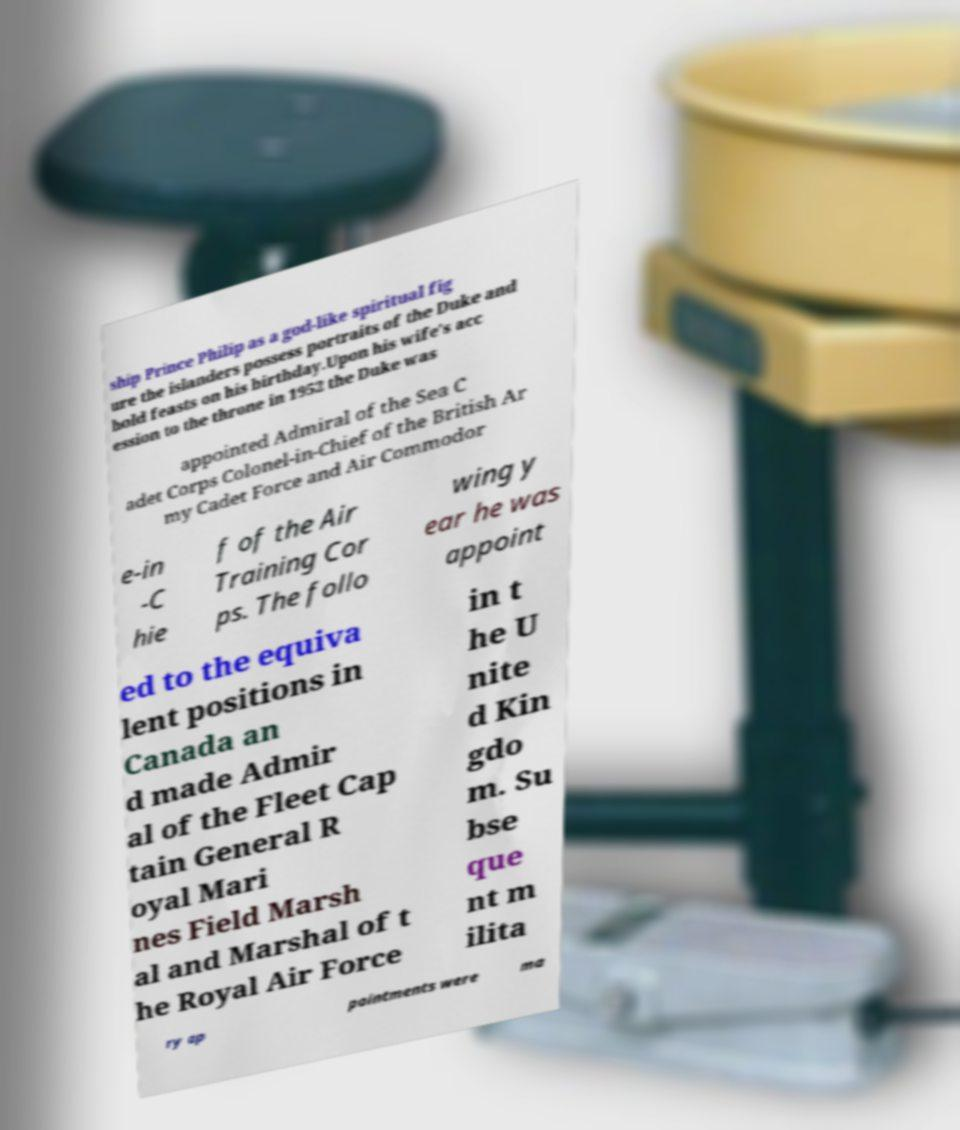Can you read and provide the text displayed in the image?This photo seems to have some interesting text. Can you extract and type it out for me? ship Prince Philip as a god-like spiritual fig ure the islanders possess portraits of the Duke and hold feasts on his birthday.Upon his wife's acc ession to the throne in 1952 the Duke was appointed Admiral of the Sea C adet Corps Colonel-in-Chief of the British Ar my Cadet Force and Air Commodor e-in -C hie f of the Air Training Cor ps. The follo wing y ear he was appoint ed to the equiva lent positions in Canada an d made Admir al of the Fleet Cap tain General R oyal Mari nes Field Marsh al and Marshal of t he Royal Air Force in t he U nite d Kin gdo m. Su bse que nt m ilita ry ap pointments were ma 